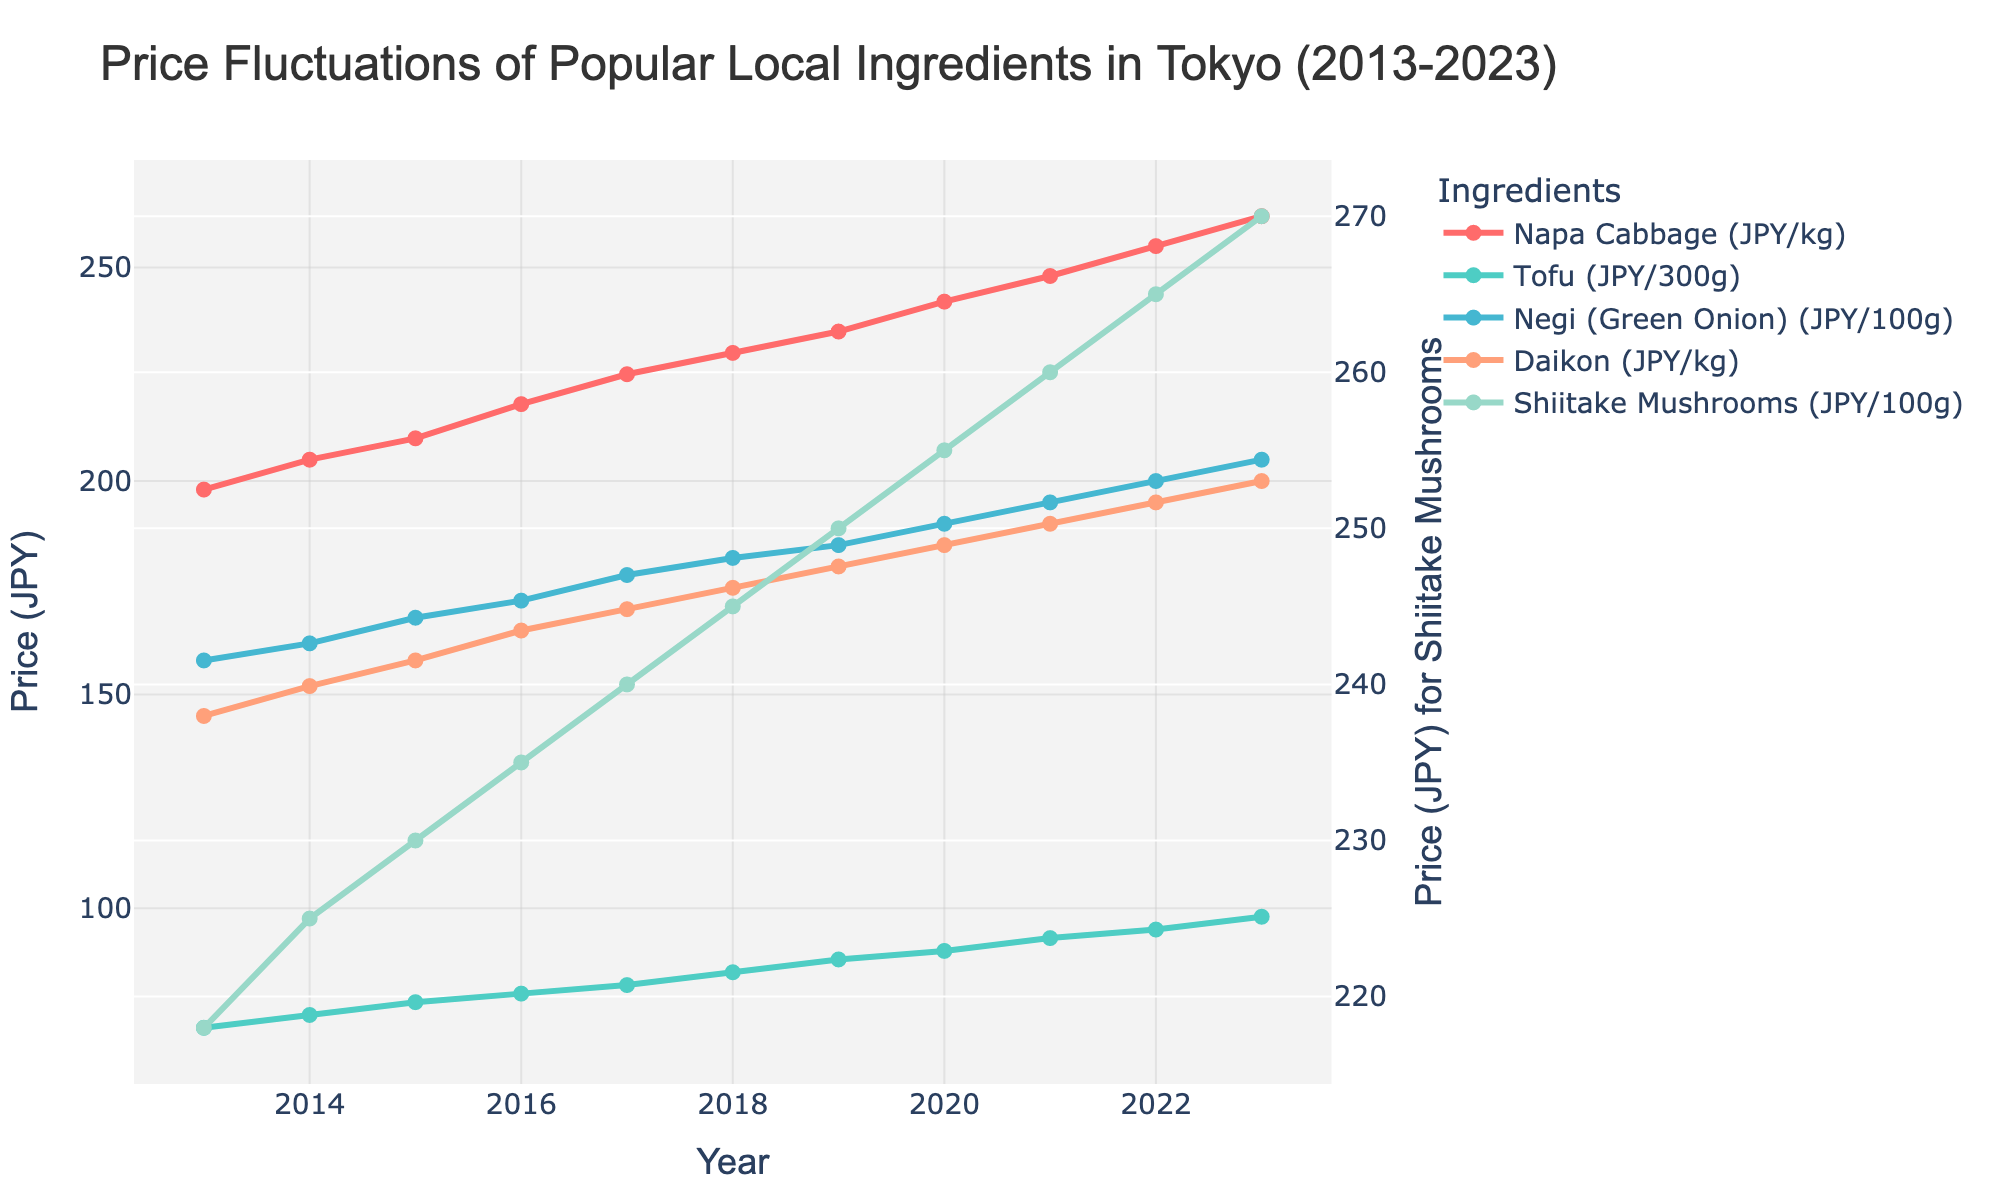Which ingredient saw the highest increase in price over the decade? To determine the ingredient with the highest increase, we calculate the price difference between 2023 and 2013 for each ingredient. Napa Cabbage: 262 - 198 = 64, Tofu: 98 - 72 = 26, Negi: 205 - 158 = 47, Daikon: 200 - 145 = 55, Shiitake Mushrooms: 270 - 218 = 52. Napa Cabbage had the highest increase.
Answer: Napa Cabbage What was the price trend for Daikon over the years? Did it continuously increase or were there any decreases? Look at the line representing Daikon and observe its general direction. The price for Daikon in 2013 was 145 JPY/kg and increased each year up to 200 JPY/kg in 2023, indicating a continuous increase with no decreases.
Answer: Continuous increase Which year saw the largest year-over-year increase in price for Tofu? Calculate the year-over-year increase for Tofu by subtracting each year's value from the previous year's value. The year-over-year increases are: 2014: 75-72=3, 2015: 78-75=3, 2016: 80-78=2, 2017: 82-80=2, 2018: 85-82=3, 2019: 88-85=3, 2020: 90-88=2, 2021: 93-90=3, 2022: 95-93=2, 2023: 98-95=3. The largest increases are 3 JPY, occurring in 2014, 2015, 2018, 2019, and 2023.
Answer: 2014, 2015, 2018, 2019, 2023 Which ingredient had the most stable price over the decade? The most stable price can be identified by the smallest total increase over the decade. Calculate the total increase for each ingredient from 2013 to 2023. Napa Cabbage: 64, Tofu: 26, Negi: 47, Daikon: 55, Shiitake Mushrooms: 52. Tofu experienced the smallest total increase, making it the most stable.
Answer: Tofu In 2020, which ingredient was the most expensive? Identify the prices of each ingredient in 2020 and compare them. Napa Cabbage: 242 JPY/kg, Tofu: 90 JPY/300g, Negi: 190 JPY/100g, Daikon: 185 JPY/kg, Shiitake Mushrooms: 255 JPY/100g. Shiitake Mushrooms had the highest price in 2020.
Answer: Shiitake Mushrooms 